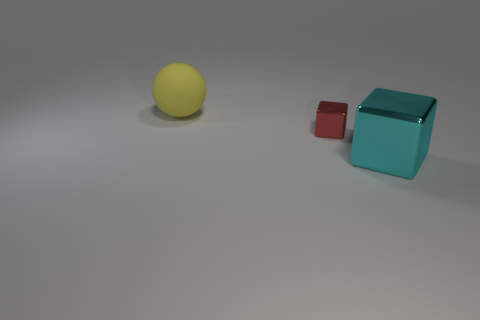Add 2 big cyan shiny spheres. How many objects exist? 5 Subtract all blocks. How many objects are left? 1 Add 3 big objects. How many big objects exist? 5 Subtract 1 red cubes. How many objects are left? 2 Subtract all green cylinders. Subtract all small red cubes. How many objects are left? 2 Add 2 small red objects. How many small red objects are left? 3 